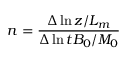Convert formula to latex. <formula><loc_0><loc_0><loc_500><loc_500>n = \frac { \Delta \ln { z / L _ { m } } } { \Delta \ln { t B _ { 0 } / M _ { 0 } } }</formula> 